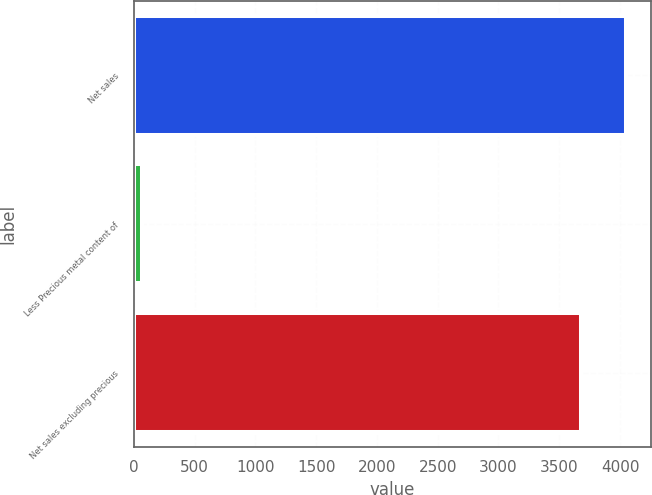<chart> <loc_0><loc_0><loc_500><loc_500><bar_chart><fcel>Net sales<fcel>Less Precious metal content of<fcel>Net sales excluding precious<nl><fcel>4049.1<fcel>64.3<fcel>3681<nl></chart> 